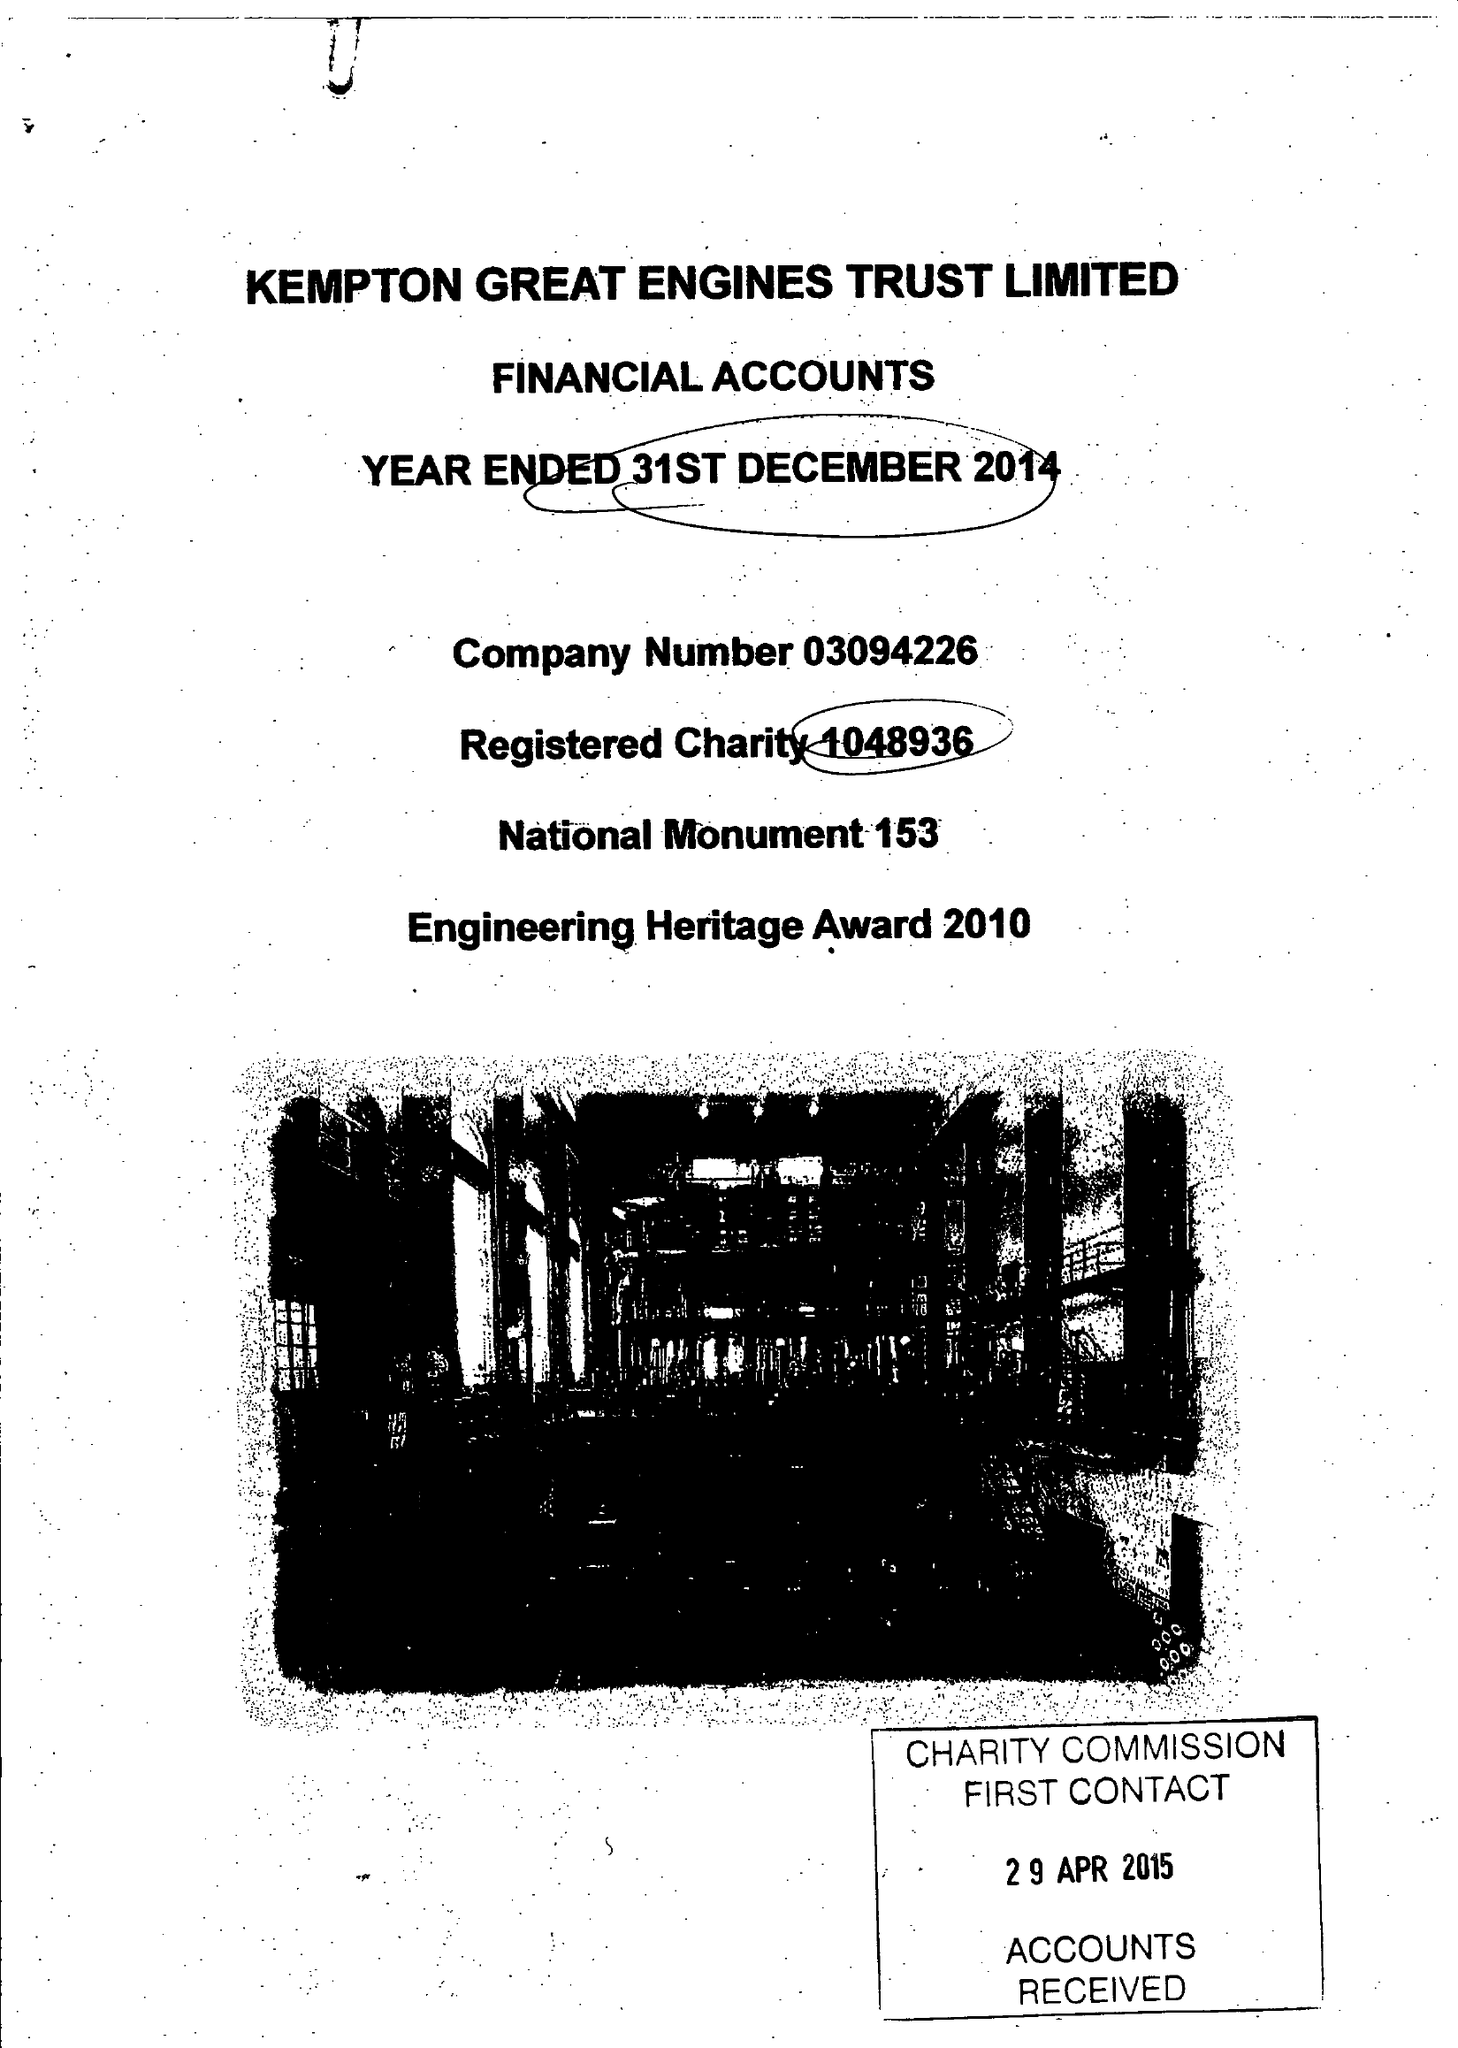What is the value for the address__postcode?
Answer the question using a single word or phrase. TW13 6XH 